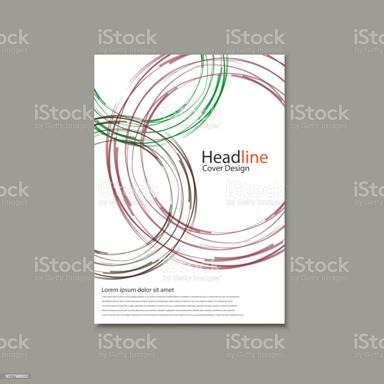What kind of business or event might use this type of brochure design? This design would be well-suited for creative industries such as graphic design studios, advertising agencies, or cultural events. The abstract and visually engaging elements indicate a focus on dynamic and innovative content, ideal for businesses that want to stand out and emphasize creativity. 